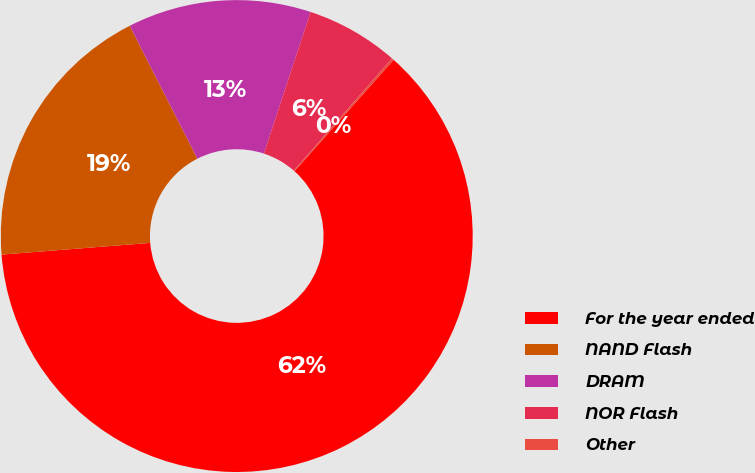<chart> <loc_0><loc_0><loc_500><loc_500><pie_chart><fcel>For the year ended<fcel>NAND Flash<fcel>DRAM<fcel>NOR Flash<fcel>Other<nl><fcel>62.17%<fcel>18.76%<fcel>12.56%<fcel>6.36%<fcel>0.15%<nl></chart> 